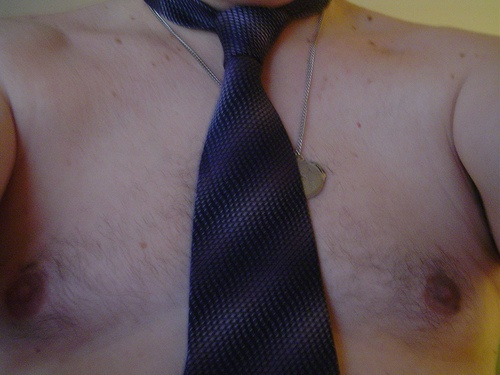Describe the objects in this image and their specific colors. I can see people in gray and black tones and tie in gray, black, navy, purple, and maroon tones in this image. 